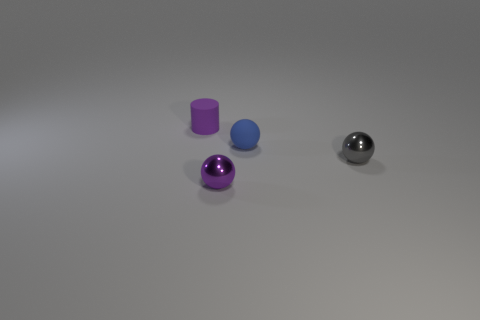Subtract all small matte spheres. How many spheres are left? 2 Subtract 1 balls. How many balls are left? 2 Add 3 blue objects. How many objects exist? 7 Subtract all green balls. Subtract all purple cylinders. How many balls are left? 3 Subtract all balls. How many objects are left? 1 Subtract all small blue spheres. Subtract all tiny blue objects. How many objects are left? 2 Add 4 balls. How many balls are left? 7 Add 4 small blue rubber cylinders. How many small blue rubber cylinders exist? 4 Subtract 0 blue blocks. How many objects are left? 4 